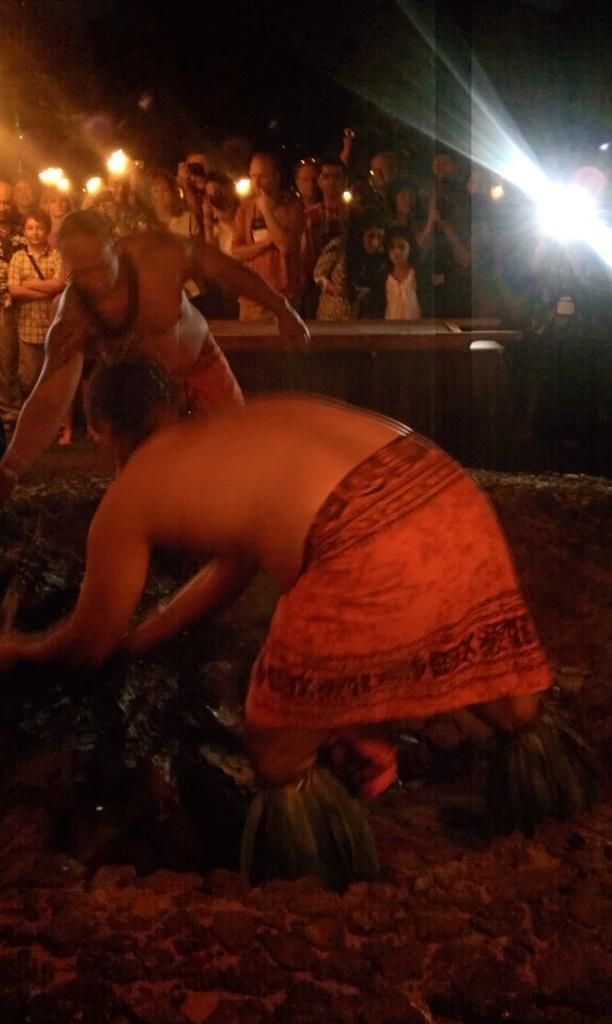How many people are in the image? There are people in the image, but the exact number is not specified. What can be seen inside the circular structure? Some people are inside a circular structure. What is the pole used for in the image? The purpose of the pole is not specified in the facts. What is the object in the image? The facts only mention that there is an object in the image, but its nature is not described. What is visible in the background of the image? The sky is visible in the image. What type of ear is visible on the doll in the image? There is no doll or ear present in the image. Is the snow falling in the image? The facts do not mention any snow or weather conditions in the image. 